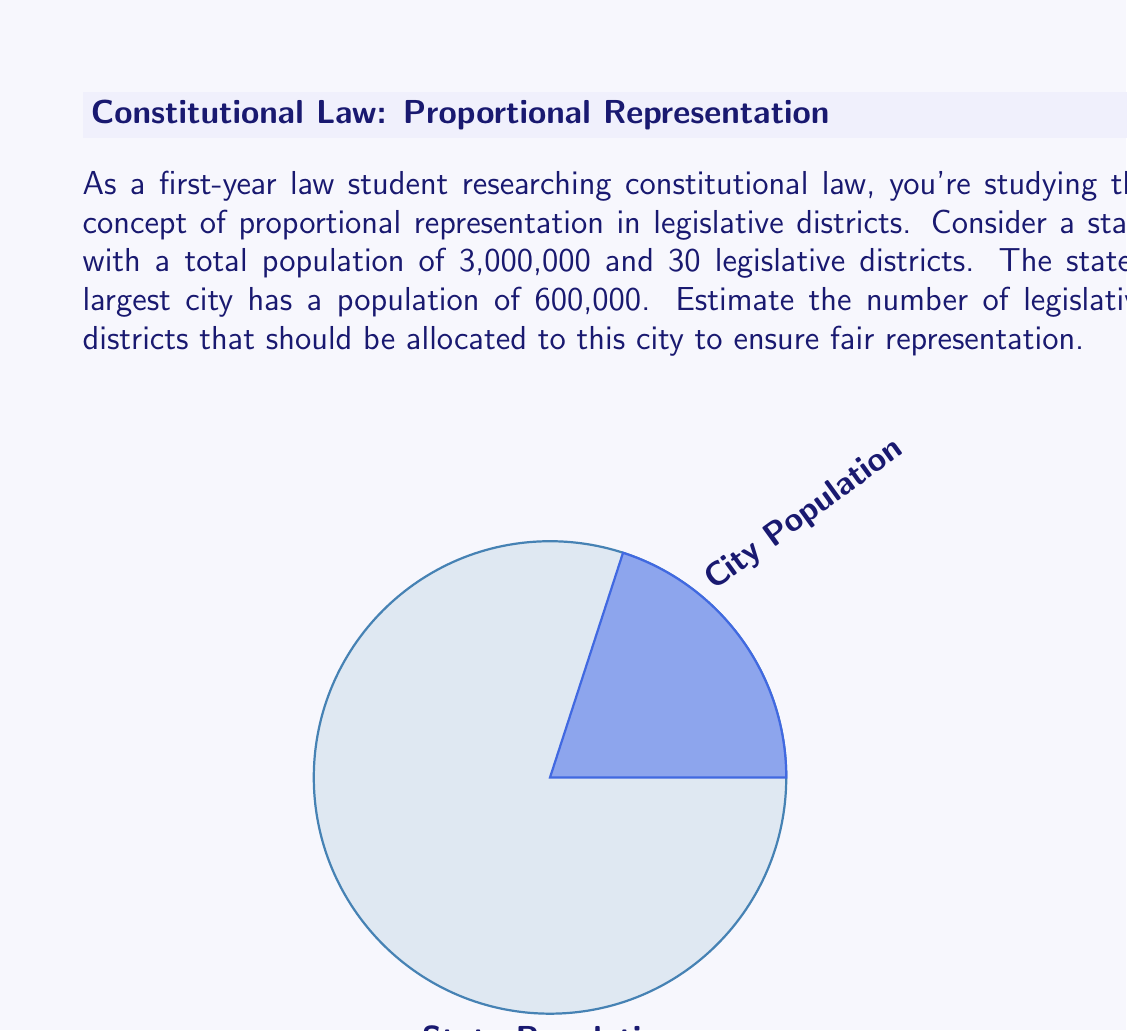What is the answer to this math problem? To solve this problem, we'll follow these steps:

1. Calculate the proportion of the state's population that lives in the city:
   $\frac{\text{City Population}}{\text{State Population}} = \frac{600,000}{3,000,000} = \frac{1}{5} = 0.2$ or 20%

2. Determine the number of districts that should be allocated to the city:
   Since the city represents 20% of the state's population, it should receive approximately 20% of the legislative districts.

3. Calculate 20% of the total number of districts:
   $20\% \text{ of } 30 = 0.2 \times 30 = 6$

Therefore, to ensure fair representation, the city should be allocated approximately 6 legislative districts.

Note: In practice, district allocation often involves more complex factors, including geographic continuity and community interests. This estimation provides a baseline for proportional representation based solely on population.
Answer: 6 districts 